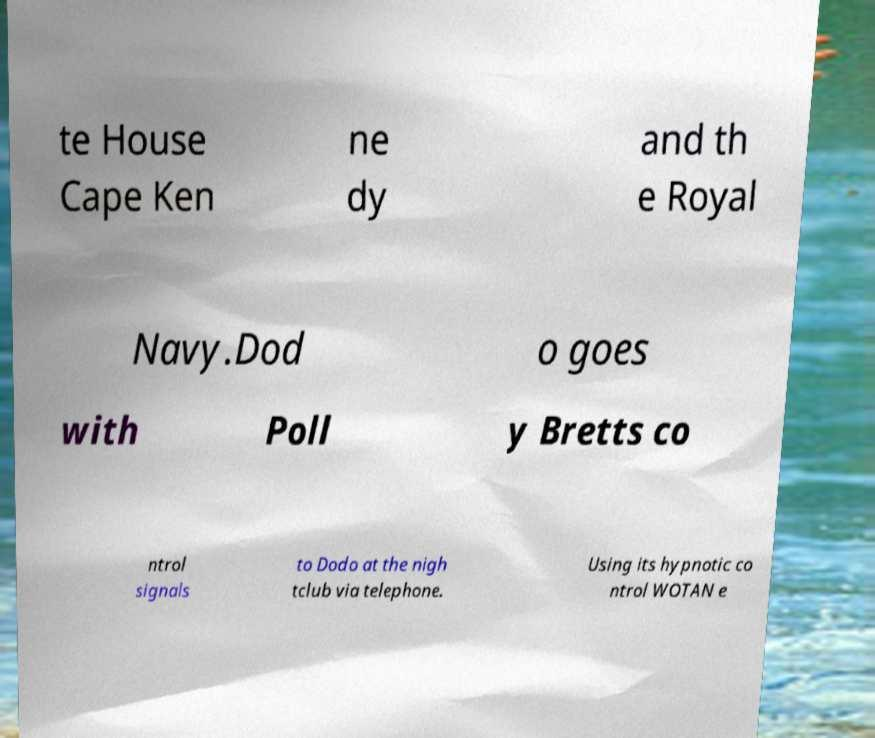Please read and relay the text visible in this image. What does it say? te House Cape Ken ne dy and th e Royal Navy.Dod o goes with Poll y Bretts co ntrol signals to Dodo at the nigh tclub via telephone. Using its hypnotic co ntrol WOTAN e 